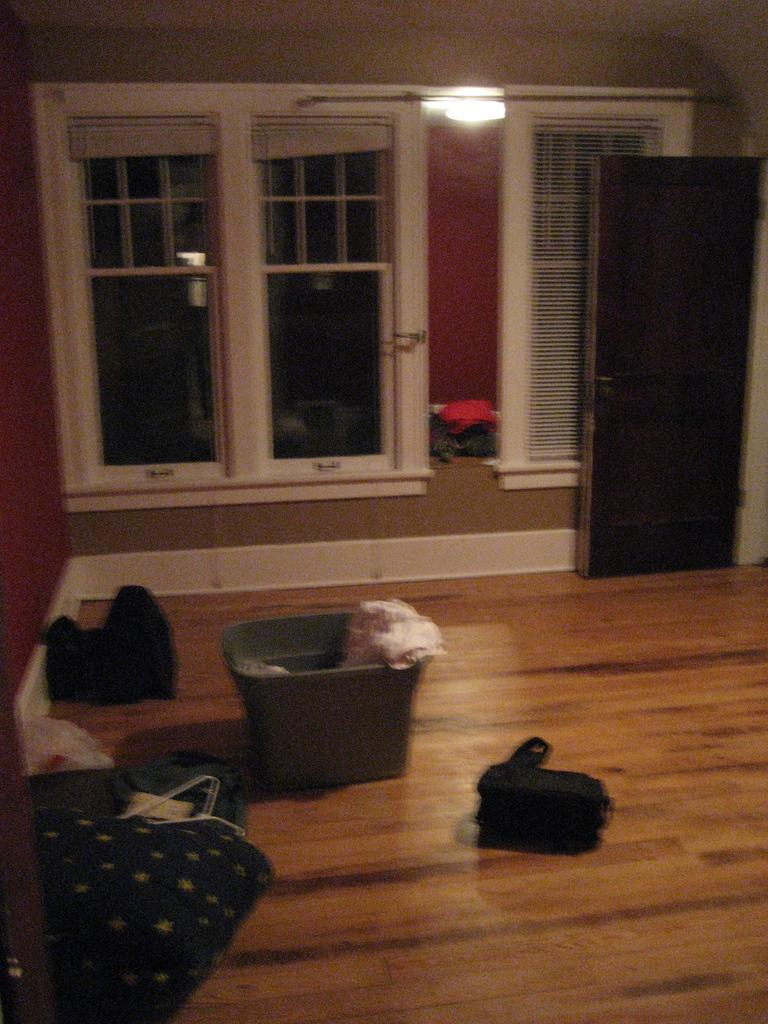What object is located in the image that can hold items? There is a basket in the image that can hold items. What type of surface is visible beneath the basket? There are additional items on the wooden floor in the image. What can be seen in the background of the image? There are glass windows and a door in the background of the image. What story is being told by the cats in the image? There are no cats present in the image, so no story can be told by them. What type of shoe is visible on the wooden floor in the image? There is no shoe visible on the wooden floor in the image. 